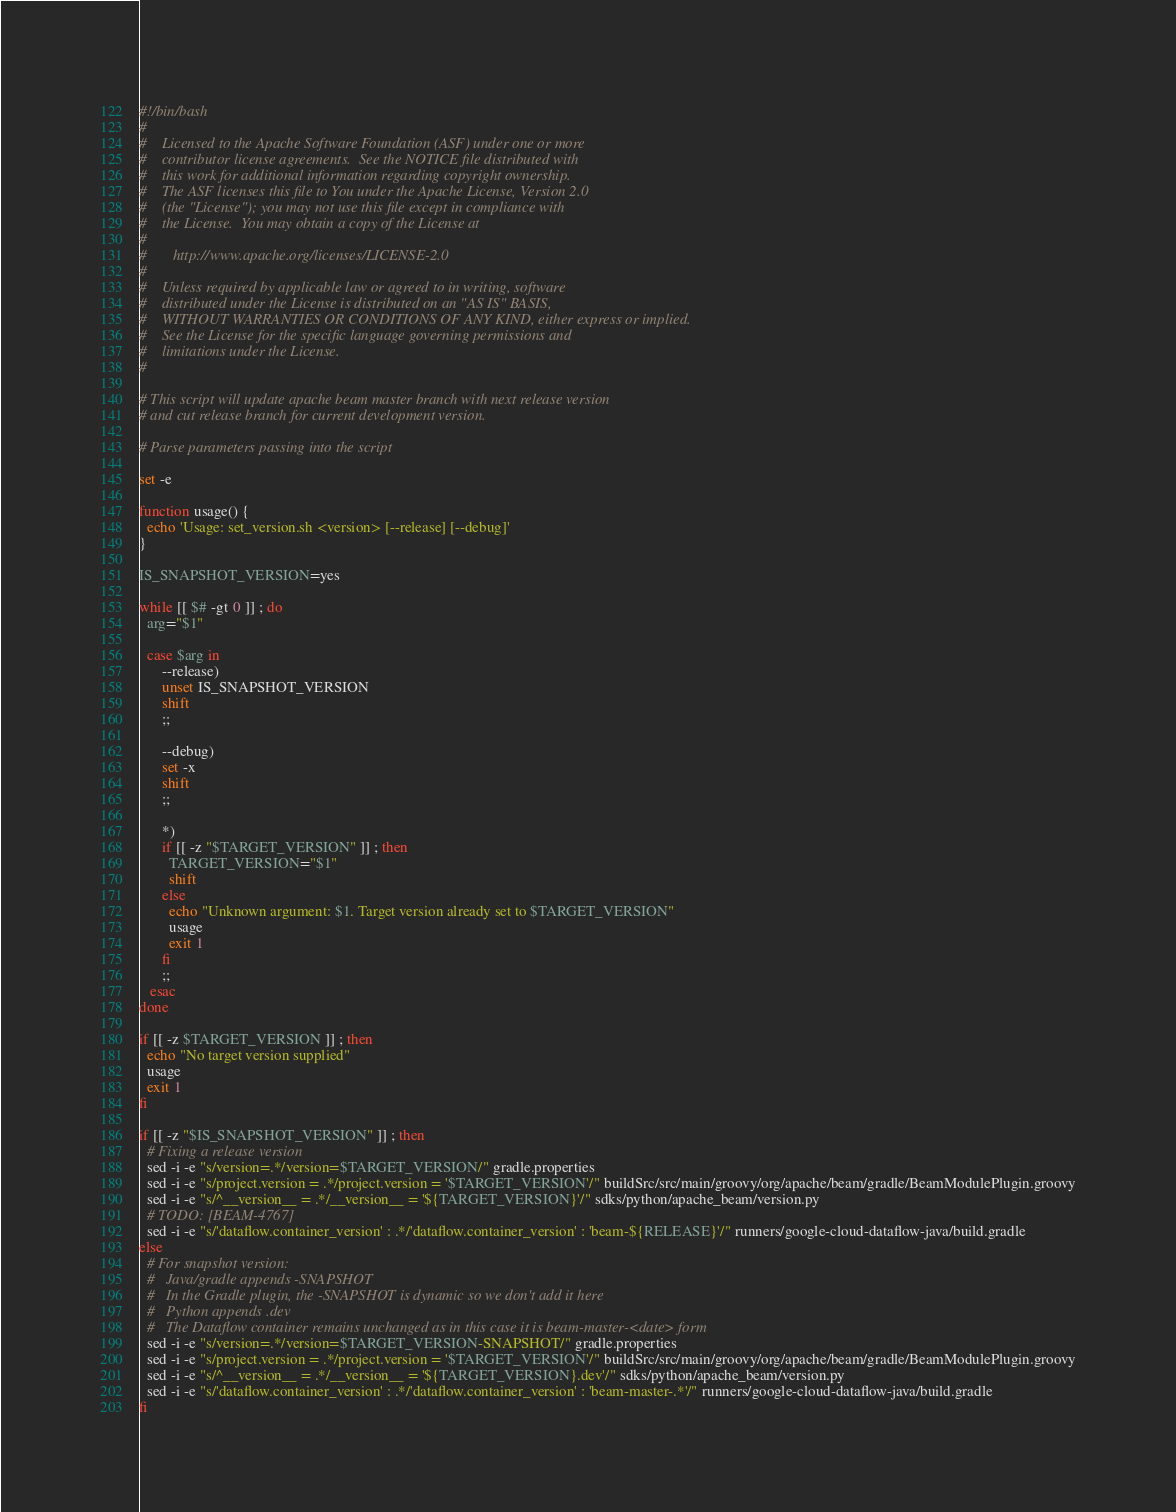<code> <loc_0><loc_0><loc_500><loc_500><_Bash_>#!/bin/bash
#
#    Licensed to the Apache Software Foundation (ASF) under one or more
#    contributor license agreements.  See the NOTICE file distributed with
#    this work for additional information regarding copyright ownership.
#    The ASF licenses this file to You under the Apache License, Version 2.0
#    (the "License"); you may not use this file except in compliance with
#    the License.  You may obtain a copy of the License at
#
#       http://www.apache.org/licenses/LICENSE-2.0
#
#    Unless required by applicable law or agreed to in writing, software
#    distributed under the License is distributed on an "AS IS" BASIS,
#    WITHOUT WARRANTIES OR CONDITIONS OF ANY KIND, either express or implied.
#    See the License for the specific language governing permissions and
#    limitations under the License.
#

# This script will update apache beam master branch with next release version
# and cut release branch for current development version.

# Parse parameters passing into the script

set -e

function usage() {
  echo 'Usage: set_version.sh <version> [--release] [--debug]'
}

IS_SNAPSHOT_VERSION=yes

while [[ $# -gt 0 ]] ; do
  arg="$1"

  case $arg in
      --release)
      unset IS_SNAPSHOT_VERSION
      shift
      ;;

      --debug)
      set -x
      shift
      ;;

      *)
      if [[ -z "$TARGET_VERSION" ]] ; then
        TARGET_VERSION="$1"
        shift
      else
        echo "Unknown argument: $1. Target version already set to $TARGET_VERSION"
        usage
        exit 1
      fi
      ;;
   esac
done

if [[ -z $TARGET_VERSION ]] ; then
  echo "No target version supplied"
  usage
  exit 1
fi

if [[ -z "$IS_SNAPSHOT_VERSION" ]] ; then
  # Fixing a release version
  sed -i -e "s/version=.*/version=$TARGET_VERSION/" gradle.properties
  sed -i -e "s/project.version = .*/project.version = '$TARGET_VERSION'/" buildSrc/src/main/groovy/org/apache/beam/gradle/BeamModulePlugin.groovy
  sed -i -e "s/^__version__ = .*/__version__ = '${TARGET_VERSION}'/" sdks/python/apache_beam/version.py
  # TODO: [BEAM-4767]
  sed -i -e "s/'dataflow.container_version' : .*/'dataflow.container_version' : 'beam-${RELEASE}'/" runners/google-cloud-dataflow-java/build.gradle
else
  # For snapshot version:
  #   Java/gradle appends -SNAPSHOT
  #   In the Gradle plugin, the -SNAPSHOT is dynamic so we don't add it here
  #   Python appends .dev
  #   The Dataflow container remains unchanged as in this case it is beam-master-<date> form
  sed -i -e "s/version=.*/version=$TARGET_VERSION-SNAPSHOT/" gradle.properties
  sed -i -e "s/project.version = .*/project.version = '$TARGET_VERSION'/" buildSrc/src/main/groovy/org/apache/beam/gradle/BeamModulePlugin.groovy
  sed -i -e "s/^__version__ = .*/__version__ = '${TARGET_VERSION}.dev'/" sdks/python/apache_beam/version.py
  sed -i -e "s/'dataflow.container_version' : .*/'dataflow.container_version' : 'beam-master-.*'/" runners/google-cloud-dataflow-java/build.gradle
fi

</code> 